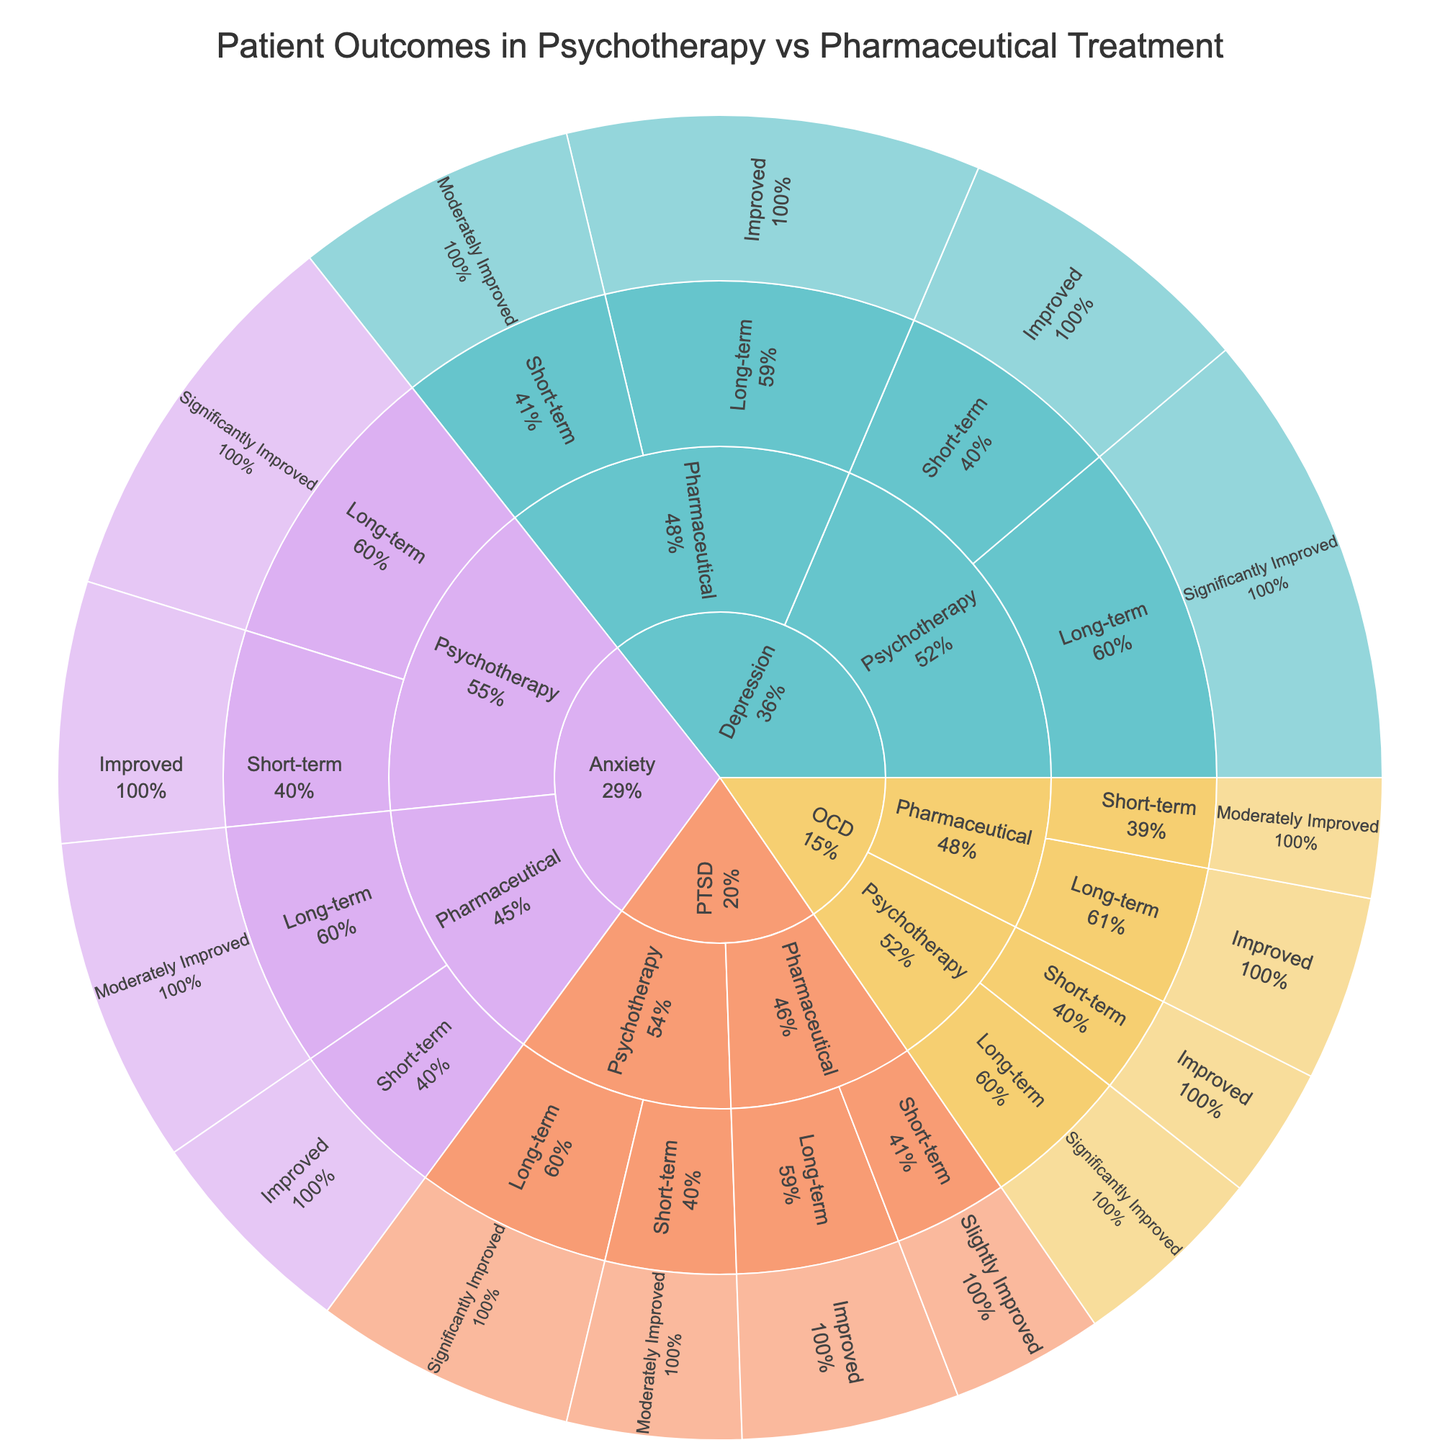What is the title of the plot? The title is displayed prominently at the top center of the Sunburst Plot. It aims to provide an overview of what the data represents.
Answer: Patient Outcomes in Psychotherapy vs Pharmaceutical Treatment Which disorder has the highest number of patients who have significantly improved with long-term psychotherapy? Look at the segments under each disorder for "Long-term" and "Significantly Improved" in the psychotherapy section. Count the patients.
Answer: Depression How many patients with OCD have improved with short-term psychotherapy? Navigate through the OCD section to find the segment for short-term psychotherapy with the outcome "Improved". Sum these patients.
Answer: 60 Compare the outcomes of short-term psychotherapy versus short-term pharmaceutical treatment for Anxiety. Which treatment had more patients improving? Compare the "Improved" segments under short-term psychotherapy and short-term pharmaceutical treatment for Anxiety.
Answer: Short-term Psychotherapy Which treatment method (psychotherapy or pharmaceutical) shows better outcomes for PTSD in the long term? Identify the outcomes and count the patients under the long-term segments for both psychotherapy and pharmaceutical treatments for PTSD.
Answer: Psychotherapy How many patients in total have shown significant improvement across all disorders and treatments? Sum the patients in all "Significantly Improved" segments, regardless of disorder or treatment type.
Answer: 600 Which outcome is more frequent for patients with Depression treated with pharmaceutical methods in the short term: Improved or Moderately Improved? Compare the patient counts in short-term pharmaceutical treatment under Depression for the outcomes "Improved" and "Moderately Improved."
Answer: Moderately Improved How many disorders were included in the analysis? Count the top-level segments in the sunburst plot which represent each disorder.
Answer: 4 Which disorder had the fewest patients treated with long-term pharmaceutical methods? Look for the segment under each disorder for long-term pharmaceutical treatment and compare the number of patients.
Answer: OCD Is there a greater percentage of patients improving with psychotherapy or pharmaceutical treatment for Anxiety in the short term? Compare the percentages of patients in the "Improved" segments under short-term psychotherapy and short-term pharmaceutical treatments for Anxiety.
Answer: Psychotherapy 